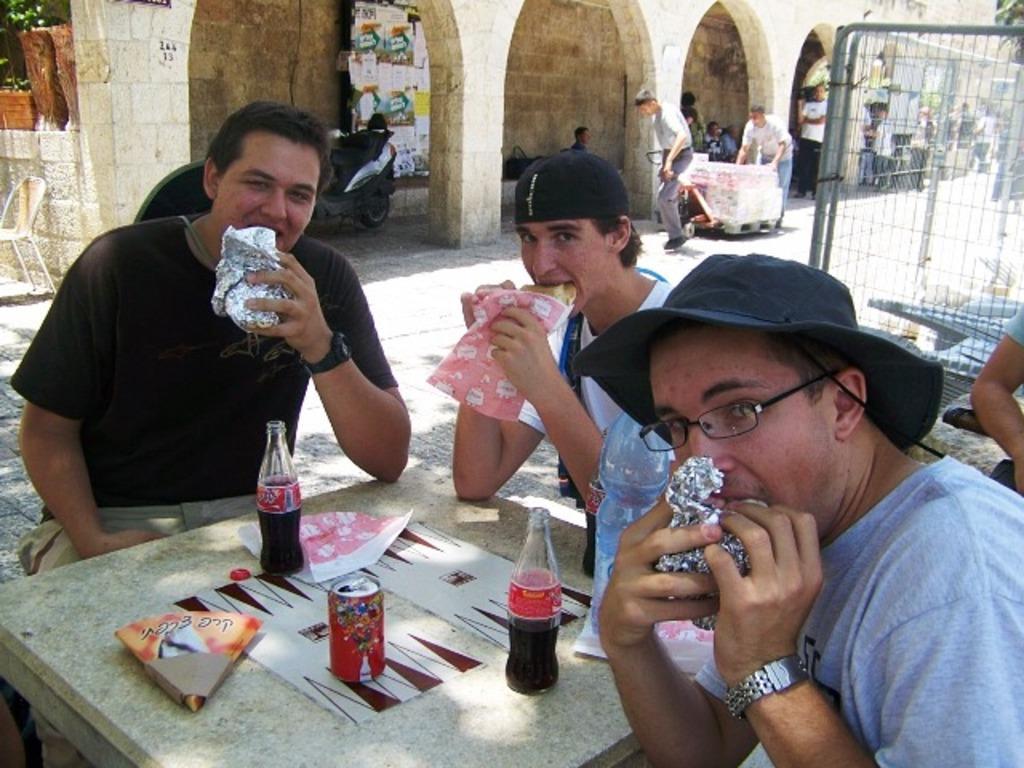In one or two sentences, can you explain what this image depicts? In this image I can see few people sitting and eating the food. These people are sitting in-front of the cement bench. On the bench I can see the papers, glass bottles and tin. To the right I can see the railing. In the background I can see the trees, chair and the building. I can see the motorbike and two people holding the trolley. In the background I can see few more people. 